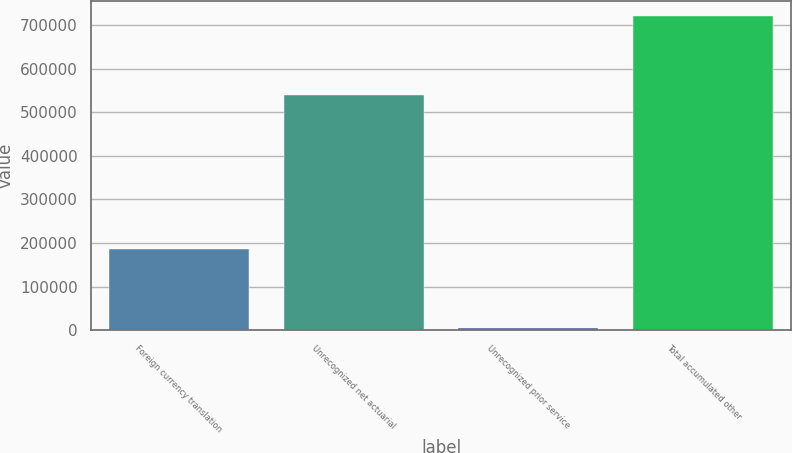Convert chart to OTSL. <chart><loc_0><loc_0><loc_500><loc_500><bar_chart><fcel>Foreign currency translation<fcel>Unrecognized net actuarial<fcel>Unrecognized prior service<fcel>Total accumulated other<nl><fcel>186998<fcel>538614<fcel>5401<fcel>720211<nl></chart> 